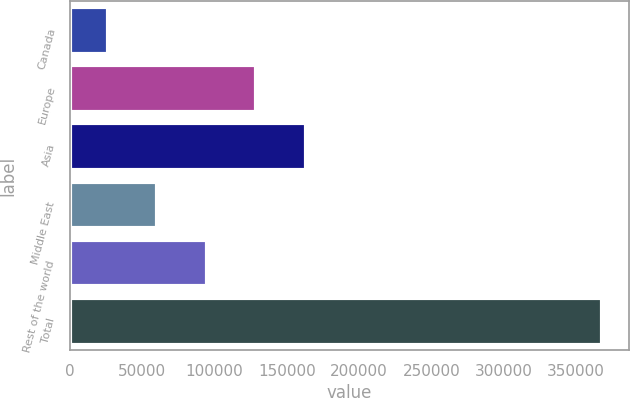Convert chart to OTSL. <chart><loc_0><loc_0><loc_500><loc_500><bar_chart><fcel>Canada<fcel>Europe<fcel>Asia<fcel>Middle East<fcel>Rest of the world<fcel>Total<nl><fcel>26171<fcel>128758<fcel>162954<fcel>60366.7<fcel>94562.4<fcel>368128<nl></chart> 